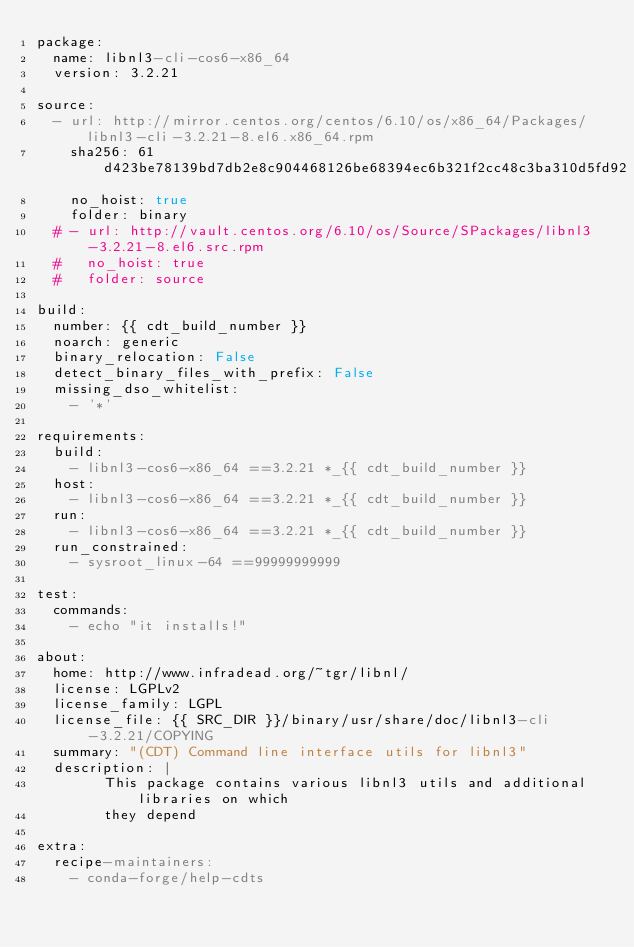Convert code to text. <code><loc_0><loc_0><loc_500><loc_500><_YAML_>package:
  name: libnl3-cli-cos6-x86_64
  version: 3.2.21

source:
  - url: http://mirror.centos.org/centos/6.10/os/x86_64/Packages/libnl3-cli-3.2.21-8.el6.x86_64.rpm
    sha256: 61d423be78139bd7db2e8c904468126be68394ec6b321f2cc48c3ba310d5fd92
    no_hoist: true
    folder: binary
  # - url: http://vault.centos.org/6.10/os/Source/SPackages/libnl3-3.2.21-8.el6.src.rpm
  #   no_hoist: true
  #   folder: source

build:
  number: {{ cdt_build_number }}
  noarch: generic
  binary_relocation: False
  detect_binary_files_with_prefix: False
  missing_dso_whitelist:
    - '*'

requirements:
  build:
    - libnl3-cos6-x86_64 ==3.2.21 *_{{ cdt_build_number }}
  host:
    - libnl3-cos6-x86_64 ==3.2.21 *_{{ cdt_build_number }}
  run:
    - libnl3-cos6-x86_64 ==3.2.21 *_{{ cdt_build_number }}
  run_constrained:
    - sysroot_linux-64 ==99999999999

test:
  commands:
    - echo "it installs!"

about:
  home: http://www.infradead.org/~tgr/libnl/
  license: LGPLv2
  license_family: LGPL
  license_file: {{ SRC_DIR }}/binary/usr/share/doc/libnl3-cli-3.2.21/COPYING
  summary: "(CDT) Command line interface utils for libnl3"
  description: |
        This package contains various libnl3 utils and additional libraries on which
        they depend

extra:
  recipe-maintainers:
    - conda-forge/help-cdts
</code> 